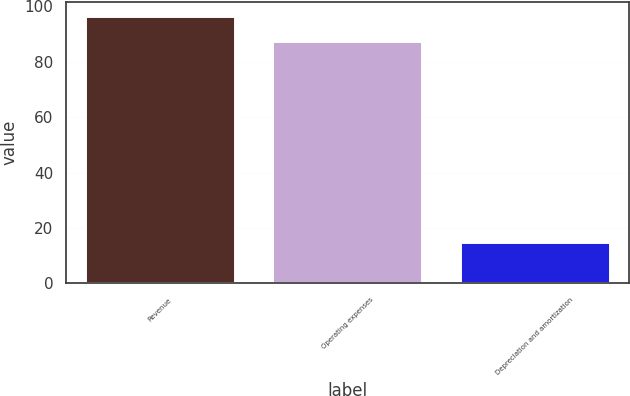Convert chart to OTSL. <chart><loc_0><loc_0><loc_500><loc_500><bar_chart><fcel>Revenue<fcel>Operating expenses<fcel>Depreciation and amortization<nl><fcel>96.6<fcel>87.5<fcel>15<nl></chart> 